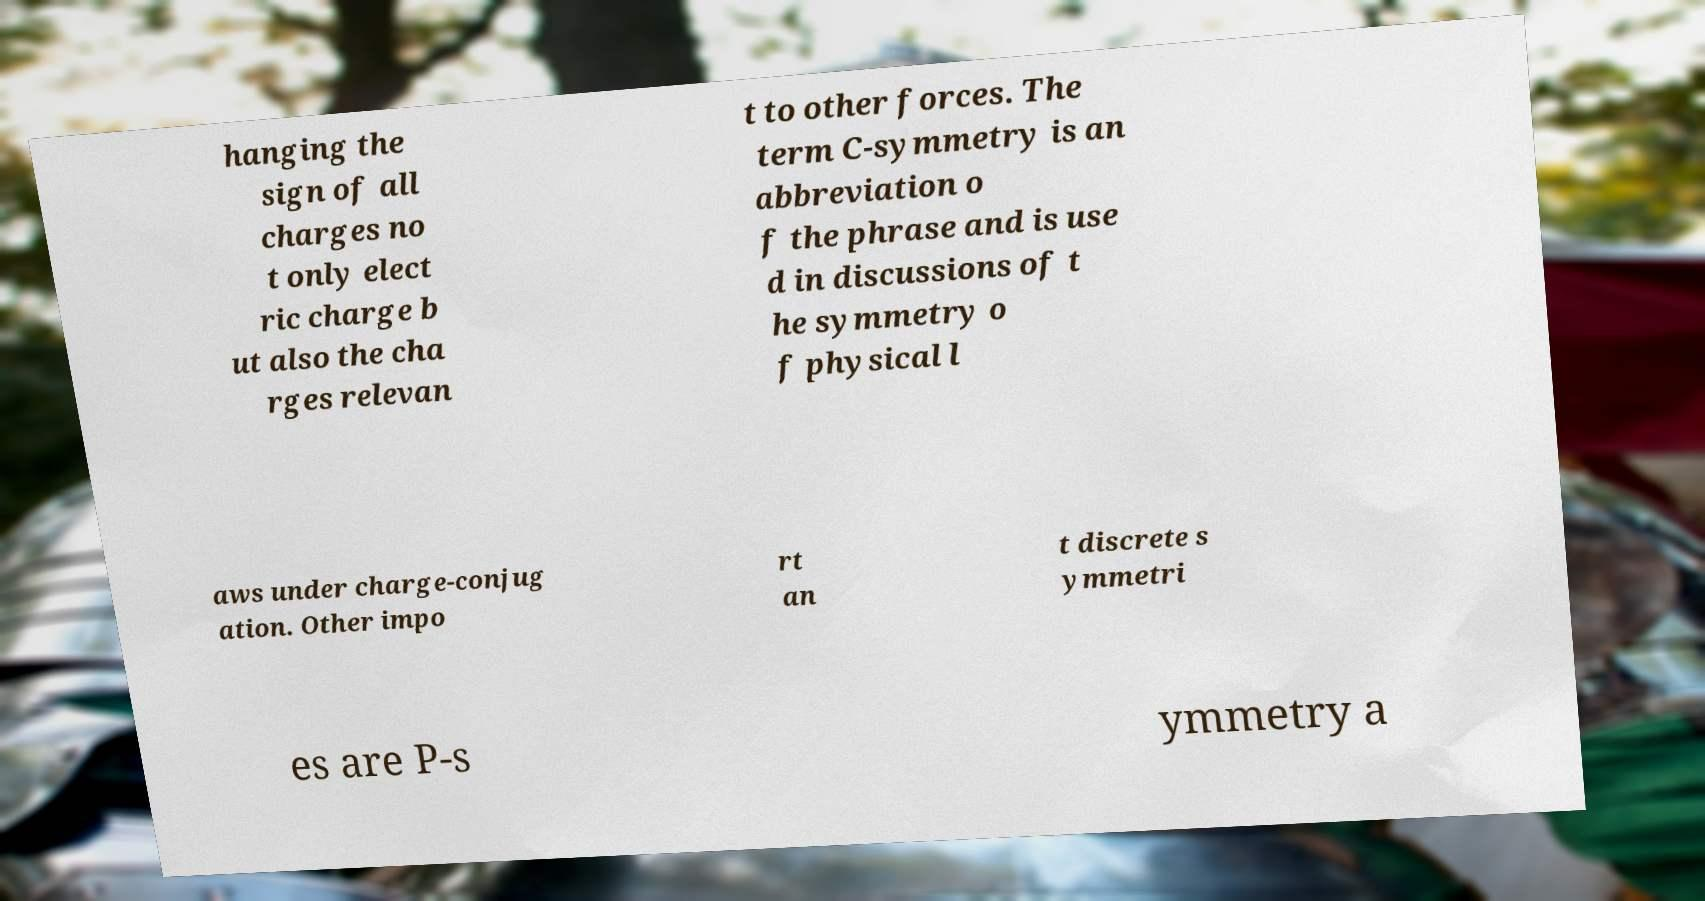I need the written content from this picture converted into text. Can you do that? hanging the sign of all charges no t only elect ric charge b ut also the cha rges relevan t to other forces. The term C-symmetry is an abbreviation o f the phrase and is use d in discussions of t he symmetry o f physical l aws under charge-conjug ation. Other impo rt an t discrete s ymmetri es are P-s ymmetry a 